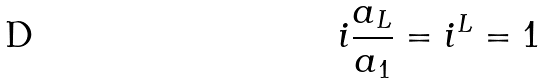Convert formula to latex. <formula><loc_0><loc_0><loc_500><loc_500>i \frac { a _ { L } } { a _ { 1 } } = i ^ { L } = 1</formula> 